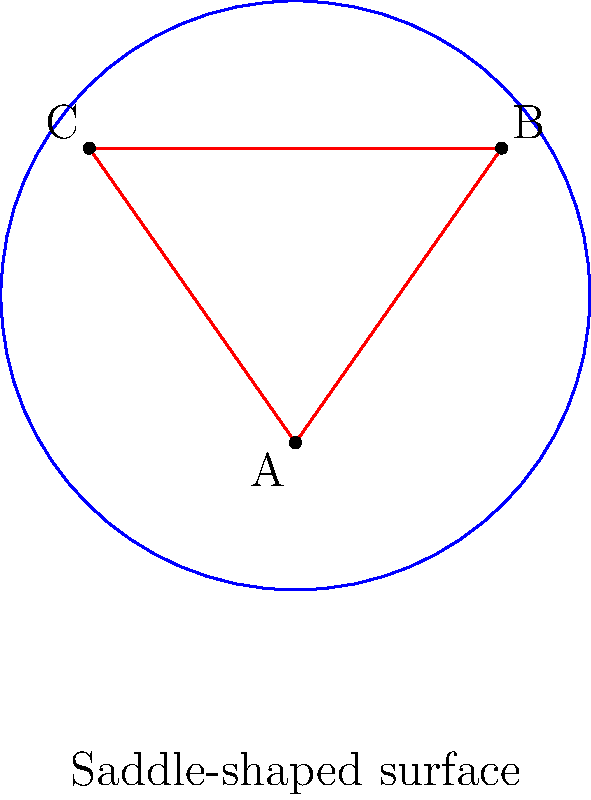Consider a triangle ABC drawn on a saddle-shaped surface, as shown in the figure. In non-Euclidean geometry, how does the sum of the interior angles of this triangle compare to the sum of angles in a triangle on a flat plane? To understand the sum of angles in a triangle on a saddle-shaped surface, let's follow these steps:

1. Recall that in Euclidean geometry (flat plane), the sum of interior angles of a triangle is always 180°.

2. In non-Euclidean geometry, the curvature of the surface affects the sum of angles in a triangle:
   - On positively curved surfaces (like a sphere), the sum is greater than 180°.
   - On negatively curved surfaces (like a saddle), the sum is less than 180°.

3. A saddle-shaped surface has negative curvature, meaning it curves upward in one direction and downward in the perpendicular direction.

4. On a negatively curved surface, parallel lines diverge, causing the angles of a triangle to be "pulled apart."

5. As a result, the sum of the interior angles of a triangle on a saddle-shaped surface is always less than 180°.

6. The exact sum depends on the size of the triangle and the degree of curvature of the surface. Larger triangles or surfaces with more pronounced curvature will have a greater deviation from 180°.

7. This property is described by the Gauss-Bonnet theorem, which relates the geometry of a surface to its topology.

In the context of swimming rehabilitation, understanding non-Euclidean geometry can be analogous to adapting your stroke technique to account for the water's resistance and your body's position, which differs from movement on land.
Answer: Less than 180° 